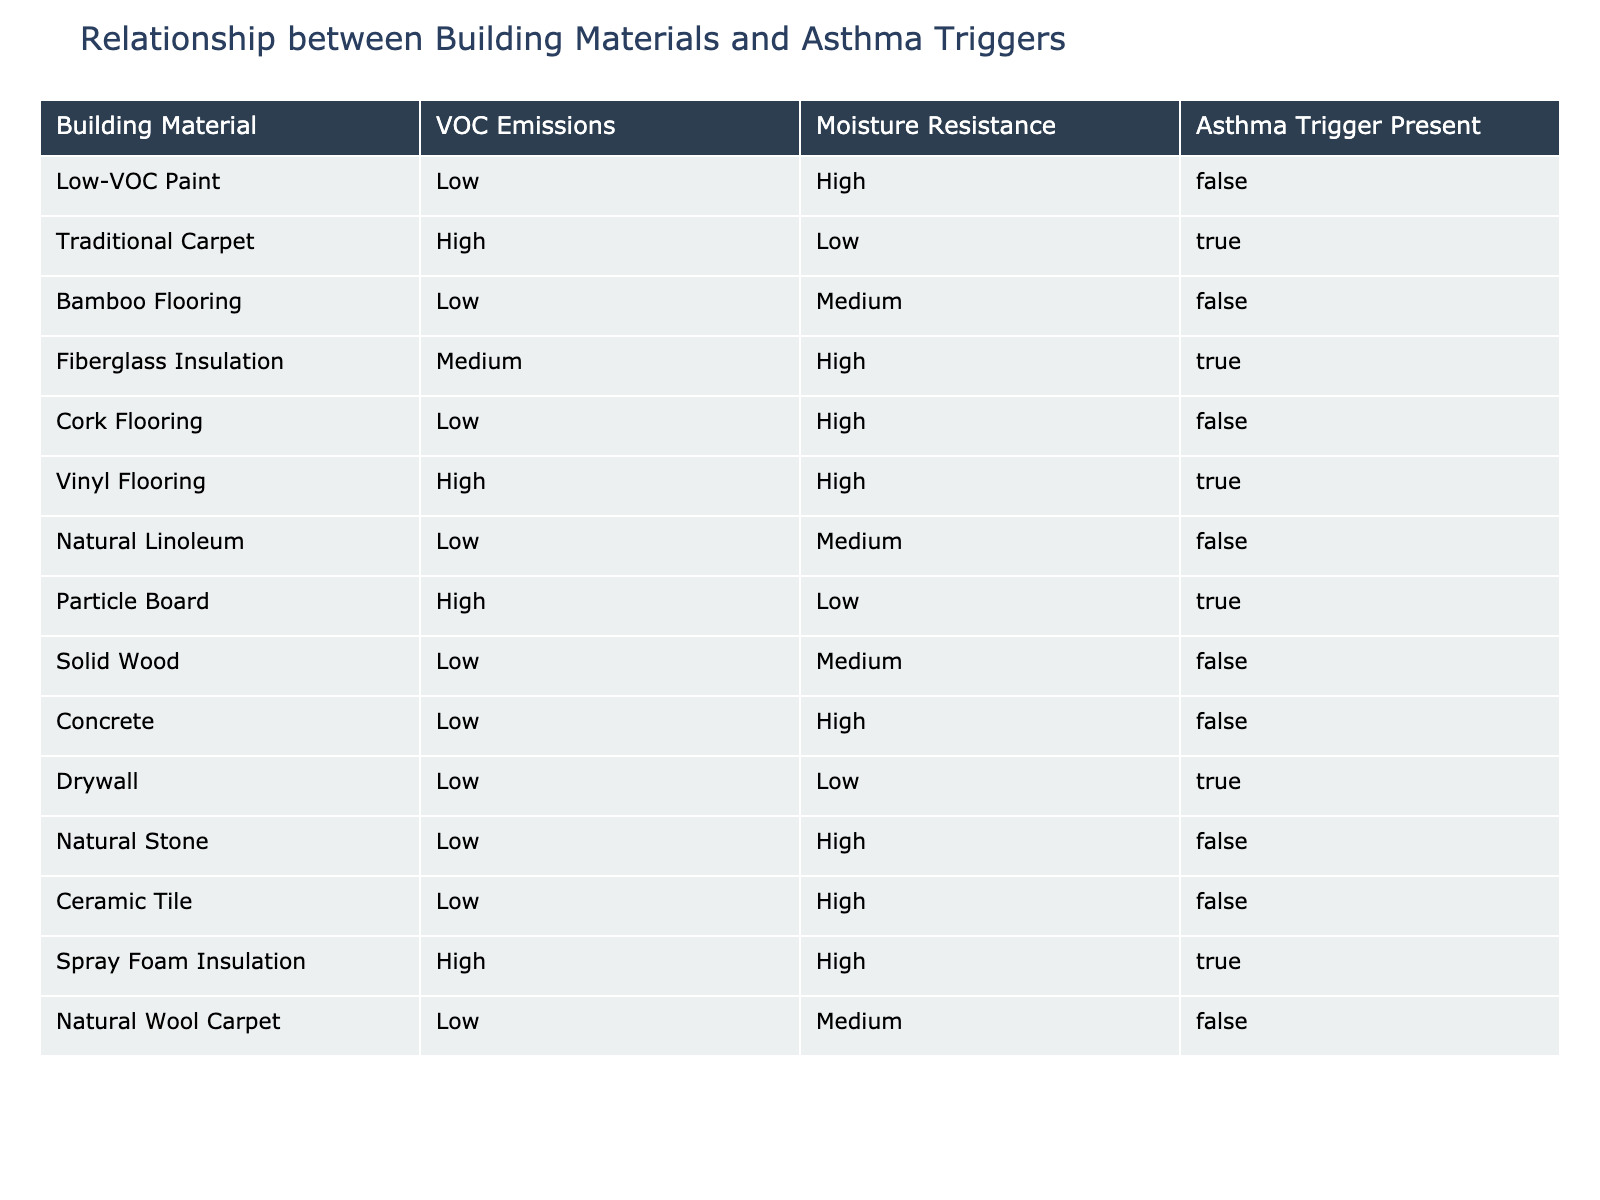What building materials cause asthma triggers? By looking at the table, the materials that lead to asthma triggers are Traditional Carpet, Fiberglass Insulation, Vinyl Flooring, Particle Board, Drywall, and Spray Foam Insulation.
Answer: Traditional Carpet, Fiberglass Insulation, Vinyl Flooring, Particle Board, Drywall, Spray Foam Insulation How many building materials have low VOC emissions but still cause asthma triggers? There are no materials listed in the table that have low VOC emissions and are also marked as causing asthma triggers.
Answer: 0 Which building material listed has the highest moisture resistance? Fiberglass Insulation, Vinyl Flooring, and Cork Flooring are all listed as having high moisture resistance, but the question is about identifying one material. We could simply mention Fiberglass Insulation as one specific option.
Answer: Fiberglass Insulation Are there any building materials with high moisture resistance that do not trigger asthma? The table shows that both Cork Flooring and Concrete have high moisture resistance and do not trigger asthma.
Answer: Yes What is the total number of building materials evaluated in the table? By counting the rows under the 'Building Material' column, we find there are 15 different materials listed in the data.
Answer: 15 Which building material has low VOC emissions and medium moisture resistance? The table indicates that Bamboo Flooring and Solid Wood both have low VOC emissions and medium moisture resistance, hence either could be the answer.
Answer: Bamboo Flooring, Solid Wood How many building materials that cause asthma triggers have high moisture resistance? The materials causing asthma triggers that also have high moisture resistance are Fiberglass Insulation, Vinyl Flooring, and Spray Foam Insulation. Summing these gives a total of 3.
Answer: 3 Is natural wool carpet a trigger for asthma? According to the table, Natural Wool Carpet does not trigger asthma because it is marked as 'False' in the relevant column.
Answer: No What percentage of building materials trigger asthma based on the table data? To find this percentage, we count 6 materials that trigger asthma from a total of 15. Thus, (6/15) * 100 equals 40%.
Answer: 40% 